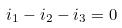Convert formula to latex. <formula><loc_0><loc_0><loc_500><loc_500>i _ { 1 } - i _ { 2 } - i _ { 3 } = 0</formula> 